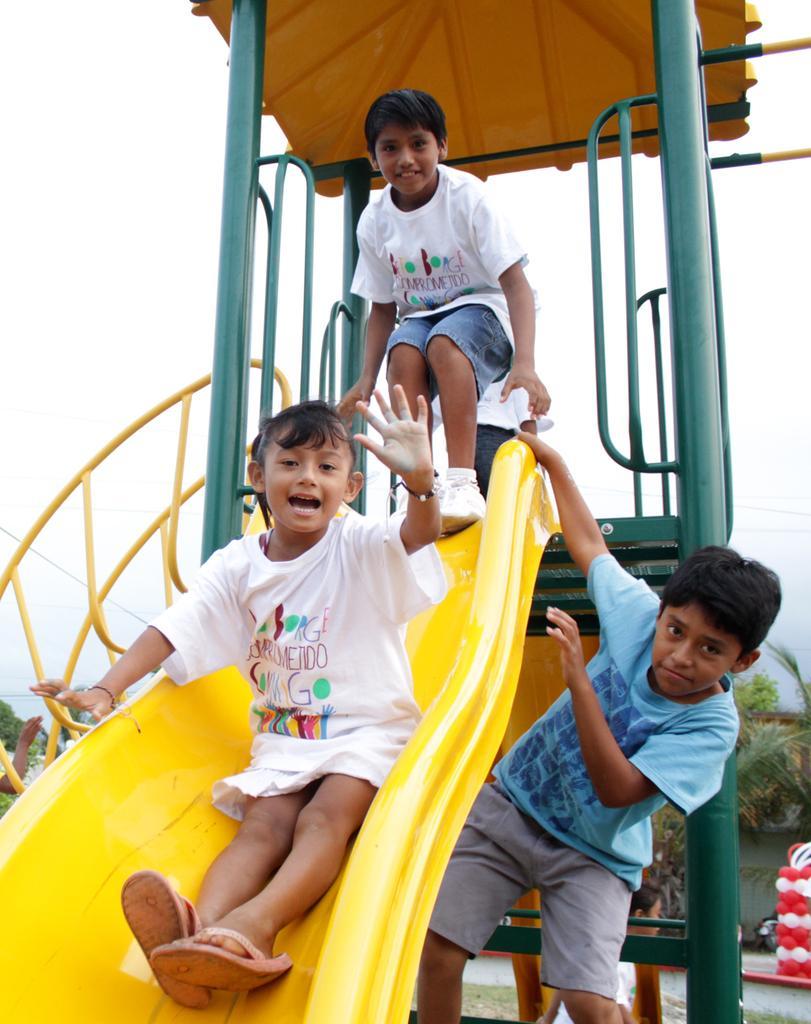Can you describe this image briefly? In this image we can see people playing on slide. In the background of the image there is sky and trees. 